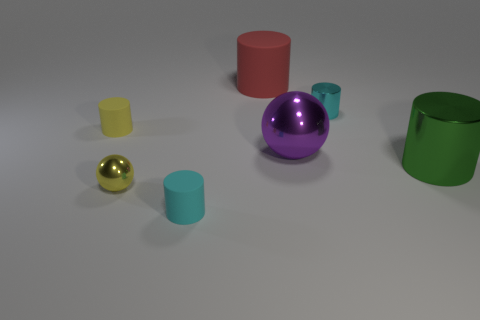Is there anything else that is made of the same material as the green cylinder?
Make the answer very short. Yes. What size is the yellow thing that is in front of the large green metallic thing?
Offer a very short reply. Small. There is a large thing that is both in front of the tiny cyan metallic object and on the left side of the big green object; what is it made of?
Your response must be concise. Metal. What material is the green cylinder that is the same size as the purple metallic thing?
Ensure brevity in your answer.  Metal. What size is the metallic ball behind the big cylinder to the right of the rubber cylinder behind the tiny cyan shiny cylinder?
Offer a very short reply. Large. There is a cyan thing that is the same material as the red thing; what is its size?
Make the answer very short. Small. Is the size of the cyan matte cylinder the same as the shiny cylinder in front of the large shiny ball?
Keep it short and to the point. No. There is a metal object to the left of the cyan matte object; what shape is it?
Your response must be concise. Sphere. There is a large shiny thing to the right of the small object to the right of the large purple metal thing; is there a tiny yellow shiny thing in front of it?
Your answer should be very brief. Yes. What is the material of the purple thing that is the same shape as the yellow shiny object?
Give a very brief answer. Metal. 